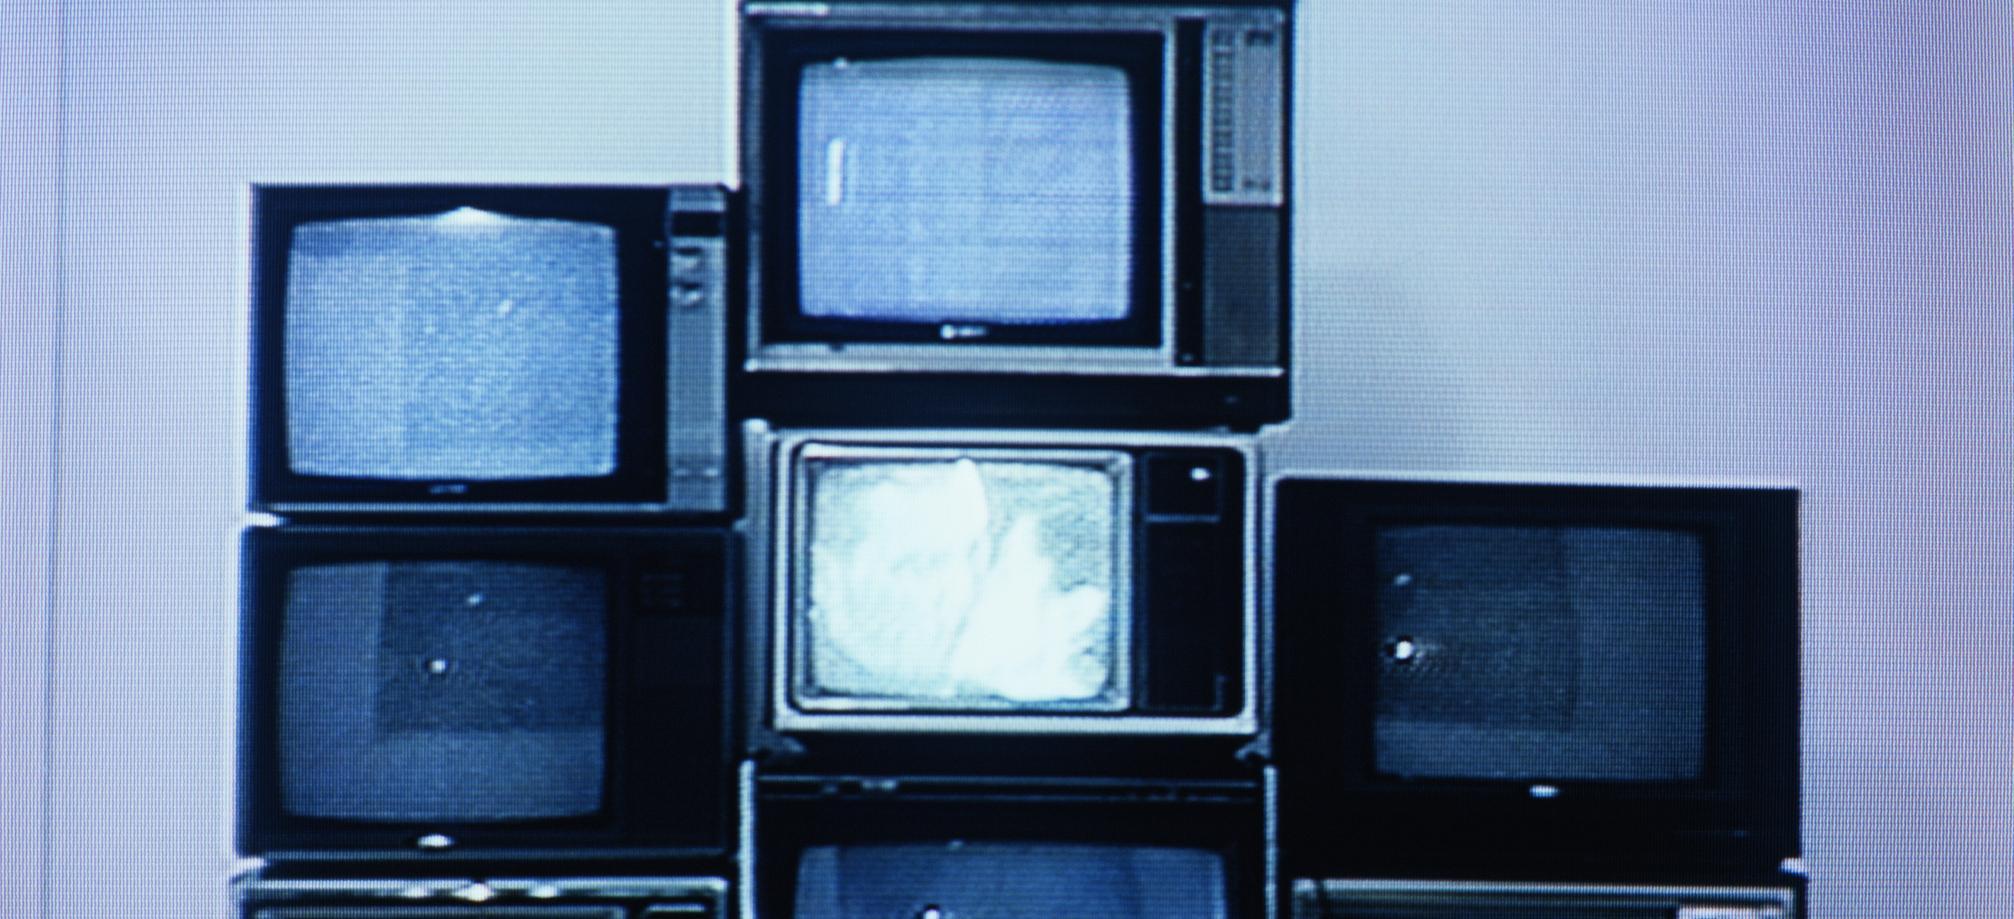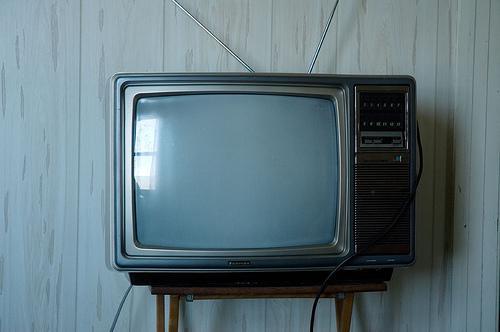The first image is the image on the left, the second image is the image on the right. Evaluate the accuracy of this statement regarding the images: "There are more screens in the left image than in the right image.". Is it true? Answer yes or no. Yes. The first image is the image on the left, the second image is the image on the right. For the images displayed, is the sentence "There are multiple monitors in one image, and a TV on a stand in the other image." factually correct? Answer yes or no. Yes. 